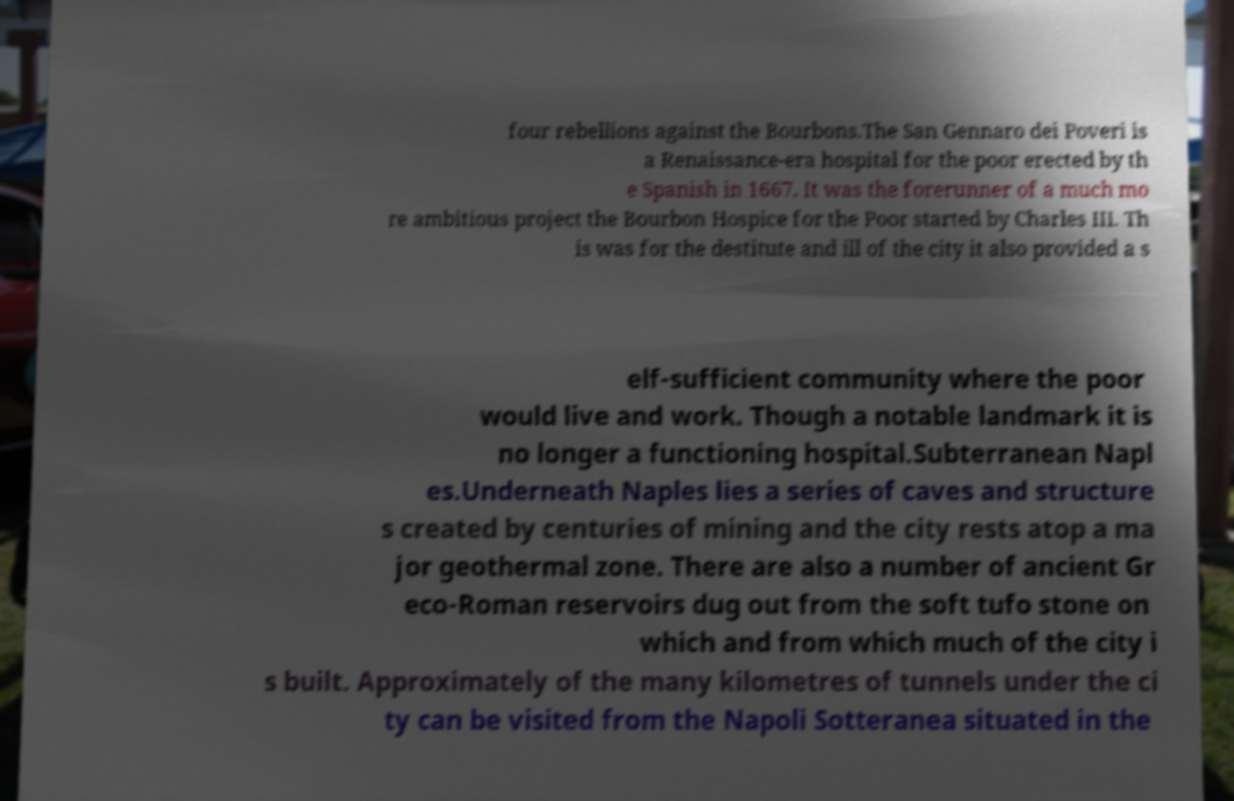Can you read and provide the text displayed in the image?This photo seems to have some interesting text. Can you extract and type it out for me? four rebellions against the Bourbons.The San Gennaro dei Poveri is a Renaissance-era hospital for the poor erected by th e Spanish in 1667. It was the forerunner of a much mo re ambitious project the Bourbon Hospice for the Poor started by Charles III. Th is was for the destitute and ill of the city it also provided a s elf-sufficient community where the poor would live and work. Though a notable landmark it is no longer a functioning hospital.Subterranean Napl es.Underneath Naples lies a series of caves and structure s created by centuries of mining and the city rests atop a ma jor geothermal zone. There are also a number of ancient Gr eco-Roman reservoirs dug out from the soft tufo stone on which and from which much of the city i s built. Approximately of the many kilometres of tunnels under the ci ty can be visited from the Napoli Sotteranea situated in the 